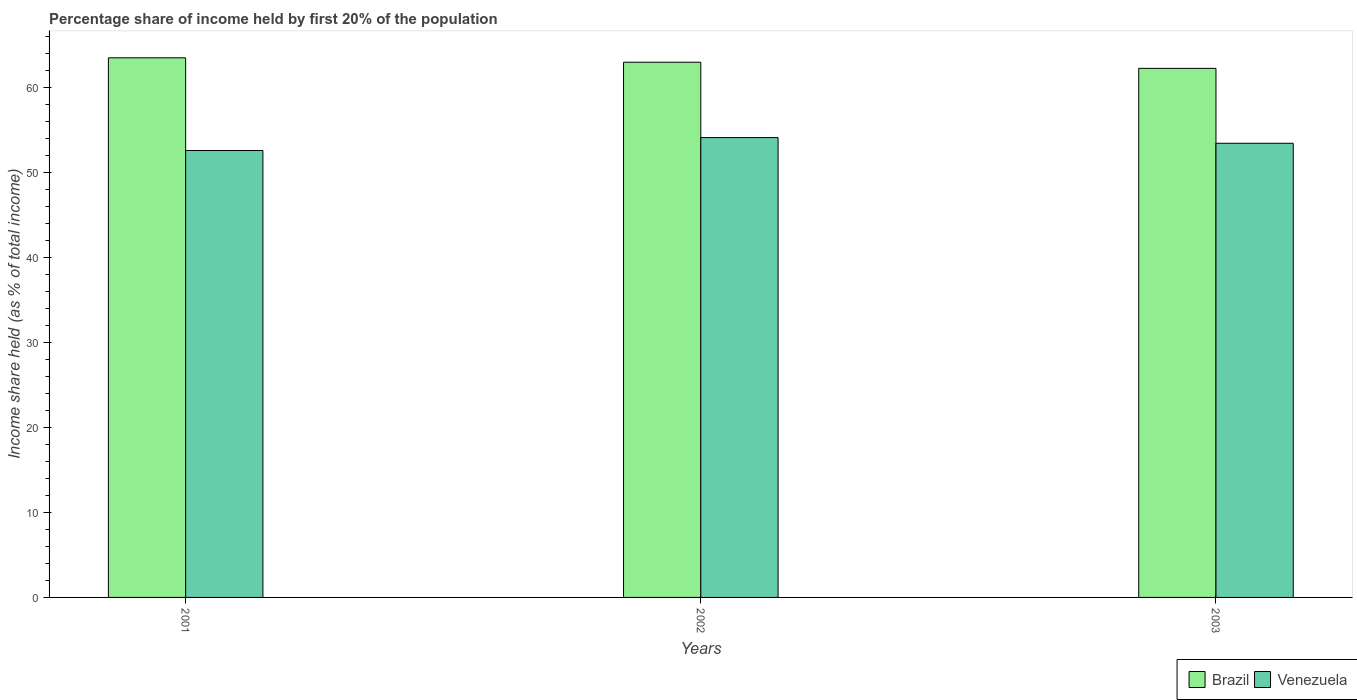How many groups of bars are there?
Make the answer very short. 3. Are the number of bars per tick equal to the number of legend labels?
Make the answer very short. Yes. What is the label of the 2nd group of bars from the left?
Give a very brief answer. 2002. What is the share of income held by first 20% of the population in Venezuela in 2001?
Offer a terse response. 52.55. Across all years, what is the maximum share of income held by first 20% of the population in Brazil?
Provide a short and direct response. 63.45. Across all years, what is the minimum share of income held by first 20% of the population in Venezuela?
Ensure brevity in your answer.  52.55. In which year was the share of income held by first 20% of the population in Brazil minimum?
Your response must be concise. 2003. What is the total share of income held by first 20% of the population in Brazil in the graph?
Provide a short and direct response. 188.59. What is the difference between the share of income held by first 20% of the population in Brazil in 2002 and that in 2003?
Offer a very short reply. 0.72. What is the difference between the share of income held by first 20% of the population in Venezuela in 2001 and the share of income held by first 20% of the population in Brazil in 2002?
Provide a short and direct response. -10.38. What is the average share of income held by first 20% of the population in Brazil per year?
Your answer should be compact. 62.86. In the year 2002, what is the difference between the share of income held by first 20% of the population in Brazil and share of income held by first 20% of the population in Venezuela?
Your response must be concise. 8.86. In how many years, is the share of income held by first 20% of the population in Brazil greater than 2 %?
Provide a succinct answer. 3. What is the ratio of the share of income held by first 20% of the population in Brazil in 2001 to that in 2003?
Your answer should be compact. 1.02. Is the share of income held by first 20% of the population in Venezuela in 2001 less than that in 2002?
Make the answer very short. Yes. What is the difference between the highest and the second highest share of income held by first 20% of the population in Venezuela?
Your answer should be very brief. 0.67. What is the difference between the highest and the lowest share of income held by first 20% of the population in Brazil?
Your answer should be very brief. 1.24. What does the 2nd bar from the left in 2001 represents?
Provide a short and direct response. Venezuela. What does the 1st bar from the right in 2002 represents?
Provide a short and direct response. Venezuela. Are all the bars in the graph horizontal?
Your answer should be very brief. No. What is the difference between two consecutive major ticks on the Y-axis?
Make the answer very short. 10. Are the values on the major ticks of Y-axis written in scientific E-notation?
Provide a succinct answer. No. Does the graph contain any zero values?
Your answer should be very brief. No. Where does the legend appear in the graph?
Keep it short and to the point. Bottom right. What is the title of the graph?
Offer a terse response. Percentage share of income held by first 20% of the population. What is the label or title of the X-axis?
Give a very brief answer. Years. What is the label or title of the Y-axis?
Offer a very short reply. Income share held (as % of total income). What is the Income share held (as % of total income) in Brazil in 2001?
Your answer should be compact. 63.45. What is the Income share held (as % of total income) in Venezuela in 2001?
Your response must be concise. 52.55. What is the Income share held (as % of total income) of Brazil in 2002?
Give a very brief answer. 62.93. What is the Income share held (as % of total income) in Venezuela in 2002?
Provide a succinct answer. 54.07. What is the Income share held (as % of total income) of Brazil in 2003?
Your response must be concise. 62.21. What is the Income share held (as % of total income) of Venezuela in 2003?
Keep it short and to the point. 53.4. Across all years, what is the maximum Income share held (as % of total income) in Brazil?
Keep it short and to the point. 63.45. Across all years, what is the maximum Income share held (as % of total income) in Venezuela?
Provide a succinct answer. 54.07. Across all years, what is the minimum Income share held (as % of total income) in Brazil?
Your answer should be compact. 62.21. Across all years, what is the minimum Income share held (as % of total income) in Venezuela?
Provide a succinct answer. 52.55. What is the total Income share held (as % of total income) of Brazil in the graph?
Give a very brief answer. 188.59. What is the total Income share held (as % of total income) in Venezuela in the graph?
Ensure brevity in your answer.  160.02. What is the difference between the Income share held (as % of total income) of Brazil in 2001 and that in 2002?
Your response must be concise. 0.52. What is the difference between the Income share held (as % of total income) of Venezuela in 2001 and that in 2002?
Ensure brevity in your answer.  -1.52. What is the difference between the Income share held (as % of total income) of Brazil in 2001 and that in 2003?
Provide a succinct answer. 1.24. What is the difference between the Income share held (as % of total income) of Venezuela in 2001 and that in 2003?
Your response must be concise. -0.85. What is the difference between the Income share held (as % of total income) of Brazil in 2002 and that in 2003?
Give a very brief answer. 0.72. What is the difference between the Income share held (as % of total income) of Venezuela in 2002 and that in 2003?
Provide a succinct answer. 0.67. What is the difference between the Income share held (as % of total income) of Brazil in 2001 and the Income share held (as % of total income) of Venezuela in 2002?
Make the answer very short. 9.38. What is the difference between the Income share held (as % of total income) of Brazil in 2001 and the Income share held (as % of total income) of Venezuela in 2003?
Your answer should be very brief. 10.05. What is the difference between the Income share held (as % of total income) of Brazil in 2002 and the Income share held (as % of total income) of Venezuela in 2003?
Provide a succinct answer. 9.53. What is the average Income share held (as % of total income) in Brazil per year?
Provide a succinct answer. 62.86. What is the average Income share held (as % of total income) in Venezuela per year?
Offer a terse response. 53.34. In the year 2001, what is the difference between the Income share held (as % of total income) of Brazil and Income share held (as % of total income) of Venezuela?
Keep it short and to the point. 10.9. In the year 2002, what is the difference between the Income share held (as % of total income) of Brazil and Income share held (as % of total income) of Venezuela?
Your response must be concise. 8.86. In the year 2003, what is the difference between the Income share held (as % of total income) in Brazil and Income share held (as % of total income) in Venezuela?
Your answer should be compact. 8.81. What is the ratio of the Income share held (as % of total income) in Brazil in 2001 to that in 2002?
Keep it short and to the point. 1.01. What is the ratio of the Income share held (as % of total income) in Venezuela in 2001 to that in 2002?
Keep it short and to the point. 0.97. What is the ratio of the Income share held (as % of total income) in Brazil in 2001 to that in 2003?
Offer a very short reply. 1.02. What is the ratio of the Income share held (as % of total income) of Venezuela in 2001 to that in 2003?
Provide a succinct answer. 0.98. What is the ratio of the Income share held (as % of total income) of Brazil in 2002 to that in 2003?
Make the answer very short. 1.01. What is the ratio of the Income share held (as % of total income) in Venezuela in 2002 to that in 2003?
Your response must be concise. 1.01. What is the difference between the highest and the second highest Income share held (as % of total income) of Brazil?
Keep it short and to the point. 0.52. What is the difference between the highest and the second highest Income share held (as % of total income) of Venezuela?
Make the answer very short. 0.67. What is the difference between the highest and the lowest Income share held (as % of total income) of Brazil?
Keep it short and to the point. 1.24. What is the difference between the highest and the lowest Income share held (as % of total income) of Venezuela?
Your response must be concise. 1.52. 